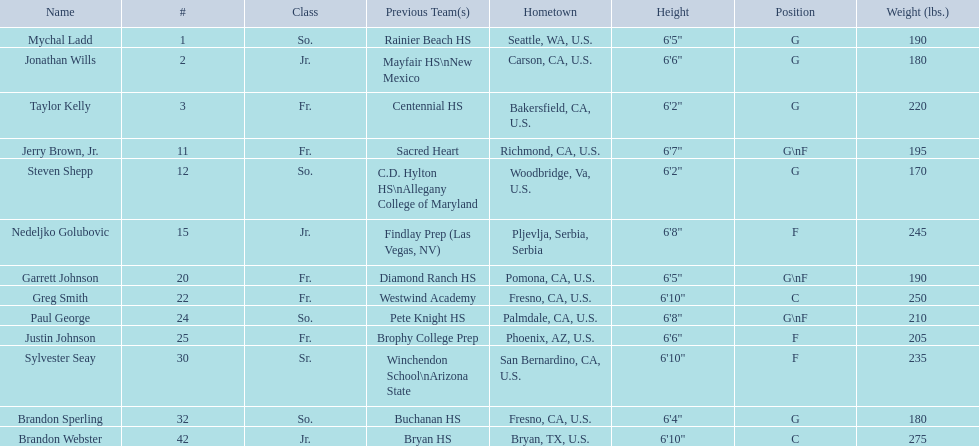Who are all the players? Mychal Ladd, Jonathan Wills, Taylor Kelly, Jerry Brown, Jr., Steven Shepp, Nedeljko Golubovic, Garrett Johnson, Greg Smith, Paul George, Justin Johnson, Sylvester Seay, Brandon Sperling, Brandon Webster. How tall are they? 6'5", 6'6", 6'2", 6'7", 6'2", 6'8", 6'5", 6'10", 6'8", 6'6", 6'10", 6'4", 6'10". What about just paul george and greg smitih? 6'10", 6'8". And which of the two is taller? Greg Smith. 